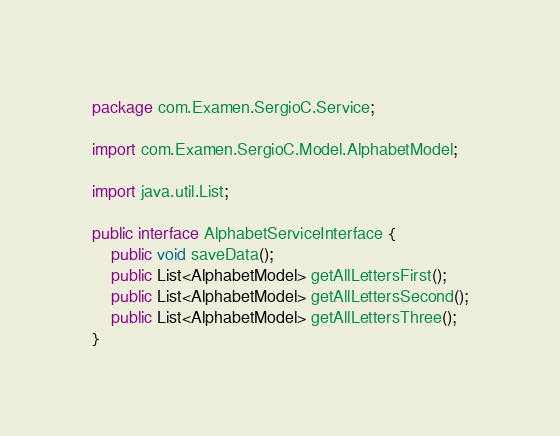Convert code to text. <code><loc_0><loc_0><loc_500><loc_500><_Java_>package com.Examen.SergioC.Service;

import com.Examen.SergioC.Model.AlphabetModel;

import java.util.List;

public interface AlphabetServiceInterface {
    public void saveData();
    public List<AlphabetModel> getAllLettersFirst();
    public List<AlphabetModel> getAllLettersSecond();
    public List<AlphabetModel> getAllLettersThree();
}
</code> 